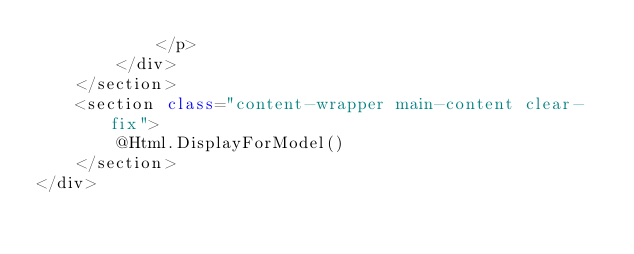Convert code to text. <code><loc_0><loc_0><loc_500><loc_500><_C#_>            </p>
        </div>
    </section>
    <section class="content-wrapper main-content clear-fix">
        @Html.DisplayForModel()
    </section>
</div>
</code> 